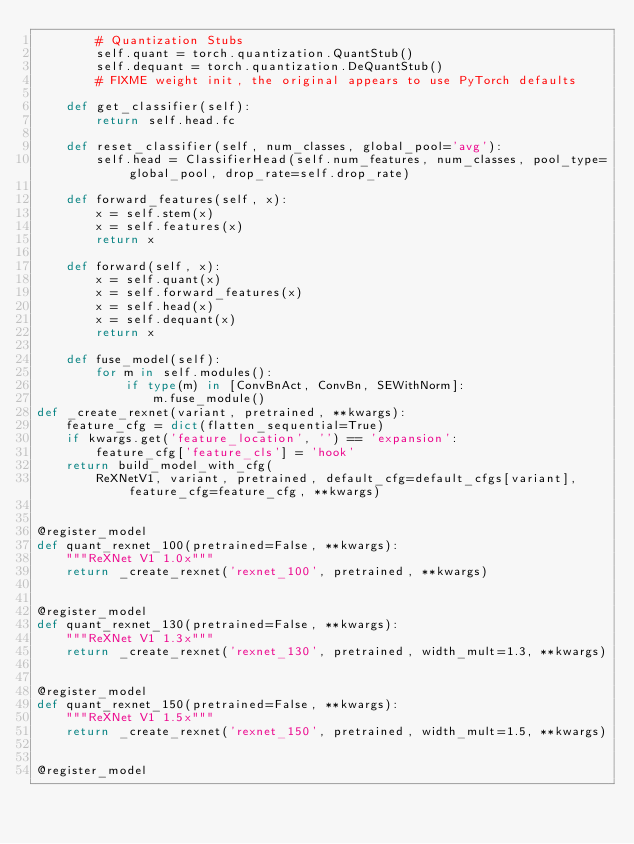<code> <loc_0><loc_0><loc_500><loc_500><_Python_>        # Quantization Stubs
        self.quant = torch.quantization.QuantStub()
        self.dequant = torch.quantization.DeQuantStub() 
        # FIXME weight init, the original appears to use PyTorch defaults

    def get_classifier(self):
        return self.head.fc

    def reset_classifier(self, num_classes, global_pool='avg'):
        self.head = ClassifierHead(self.num_features, num_classes, pool_type=global_pool, drop_rate=self.drop_rate)

    def forward_features(self, x):
        x = self.stem(x)
        x = self.features(x)
        return x

    def forward(self, x):
        x = self.quant(x)
        x = self.forward_features(x)
        x = self.head(x)
        x = self.dequant(x)
        return x

    def fuse_model(self):           
        for m in self.modules():
            if type(m) in [ConvBnAct, ConvBn, SEWithNorm]:
                m.fuse_module()
def _create_rexnet(variant, pretrained, **kwargs):
    feature_cfg = dict(flatten_sequential=True)
    if kwargs.get('feature_location', '') == 'expansion':
        feature_cfg['feature_cls'] = 'hook'
    return build_model_with_cfg(
        ReXNetV1, variant, pretrained, default_cfg=default_cfgs[variant], feature_cfg=feature_cfg, **kwargs)


@register_model
def quant_rexnet_100(pretrained=False, **kwargs):
    """ReXNet V1 1.0x"""
    return _create_rexnet('rexnet_100', pretrained, **kwargs)


@register_model
def quant_rexnet_130(pretrained=False, **kwargs):
    """ReXNet V1 1.3x"""
    return _create_rexnet('rexnet_130', pretrained, width_mult=1.3, **kwargs)


@register_model
def quant_rexnet_150(pretrained=False, **kwargs):
    """ReXNet V1 1.5x"""
    return _create_rexnet('rexnet_150', pretrained, width_mult=1.5, **kwargs)


@register_model</code> 